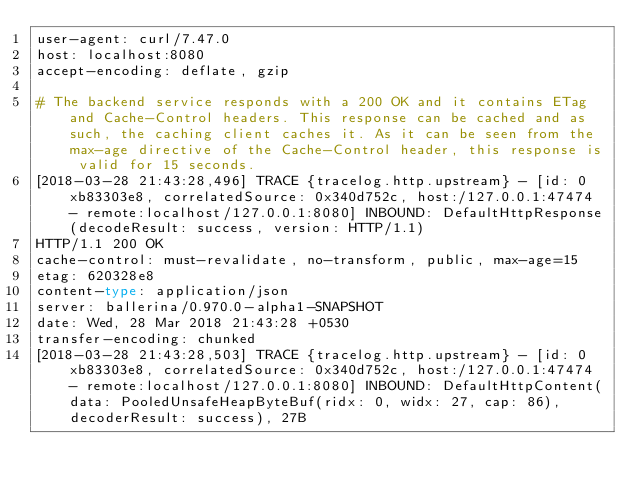Convert code to text. <code><loc_0><loc_0><loc_500><loc_500><_Bash_>user-agent: curl/7.47.0
host: localhost:8080
accept-encoding: deflate, gzip

# The backend service responds with a 200 OK and it contains ETag and Cache-Control headers. This response can be cached and as such, the caching client caches it. As it can be seen from the max-age directive of the Cache-Control header, this response is valid for 15 seconds.
[2018-03-28 21:43:28,496] TRACE {tracelog.http.upstream} - [id: 0xb83303e8, correlatedSource: 0x340d752c, host:/127.0.0.1:47474 - remote:localhost/127.0.0.1:8080] INBOUND: DefaultHttpResponse(decodeResult: success, version: HTTP/1.1)
HTTP/1.1 200 OK
cache-control: must-revalidate, no-transform, public, max-age=15
etag: 620328e8
content-type: application/json
server: ballerina/0.970.0-alpha1-SNAPSHOT
date: Wed, 28 Mar 2018 21:43:28 +0530
transfer-encoding: chunked
[2018-03-28 21:43:28,503] TRACE {tracelog.http.upstream} - [id: 0xb83303e8, correlatedSource: 0x340d752c, host:/127.0.0.1:47474 - remote:localhost/127.0.0.1:8080] INBOUND: DefaultHttpContent(data: PooledUnsafeHeapByteBuf(ridx: 0, widx: 27, cap: 86), decoderResult: success), 27B</code> 